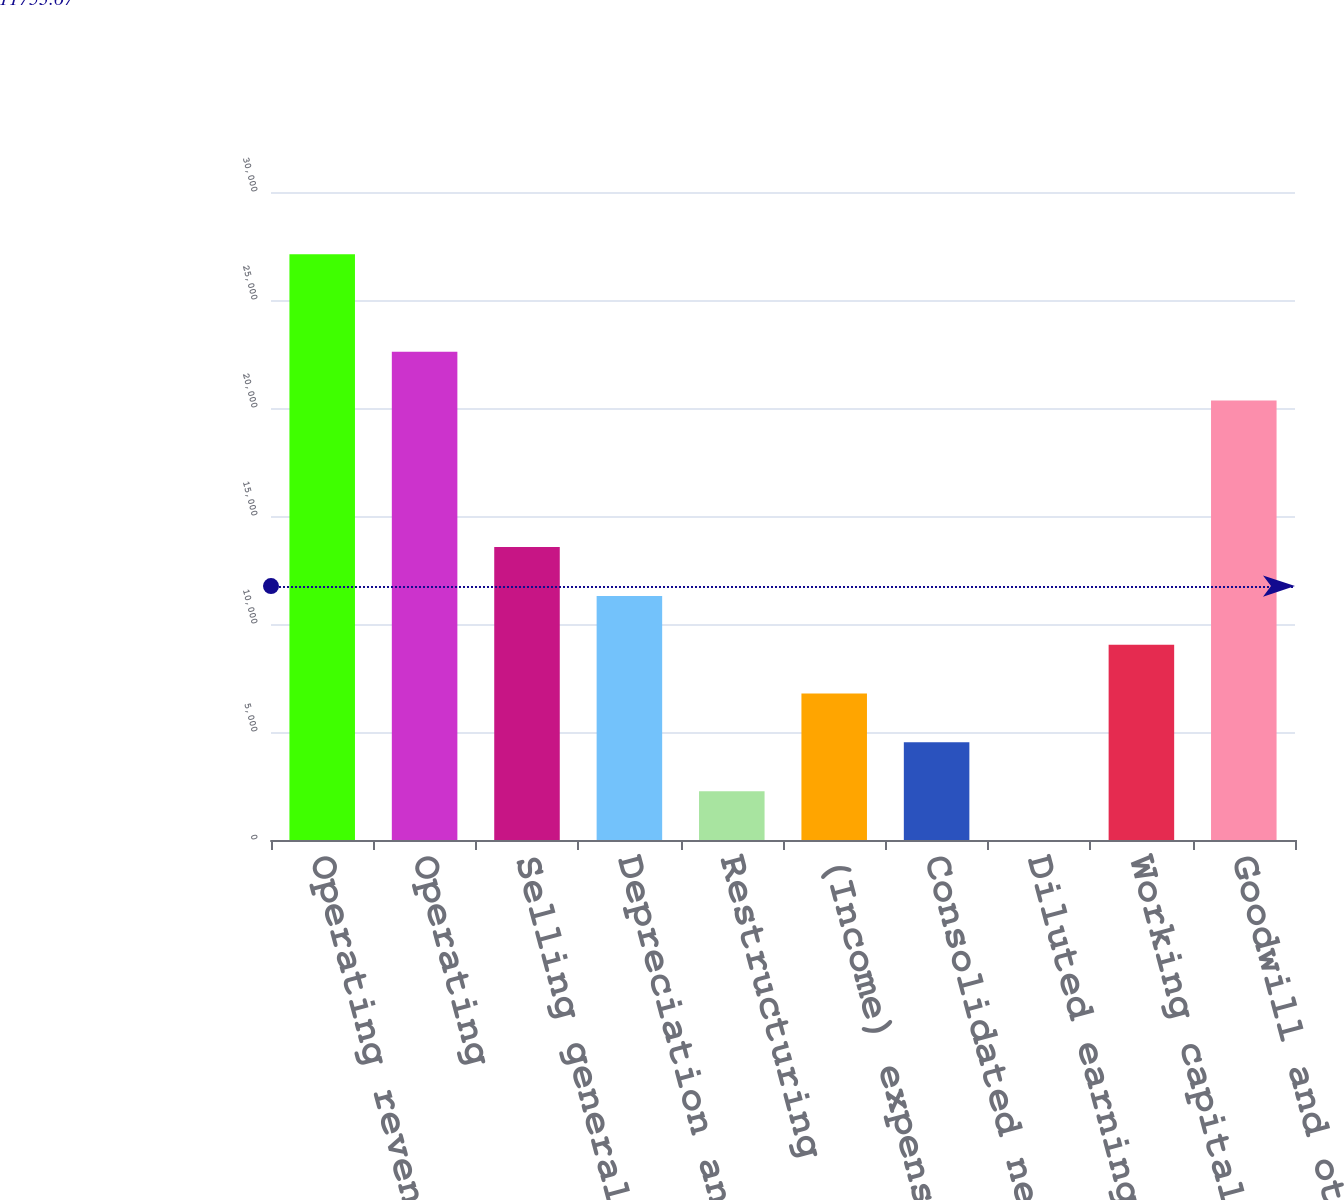Convert chart. <chart><loc_0><loc_0><loc_500><loc_500><bar_chart><fcel>Operating revenues<fcel>Operating<fcel>Selling general and<fcel>Depreciation and amortization<fcel>Restructuring<fcel>(Income) expense from<fcel>Consolidated net income<fcel>Diluted earnings per common<fcel>Working capital (deficit)<fcel>Goodwill and other intangible<nl><fcel>27123.6<fcel>22603<fcel>13561.9<fcel>11301.6<fcel>2260.49<fcel>6781.05<fcel>4520.77<fcel>0.21<fcel>9041.33<fcel>20342.7<nl></chart> 